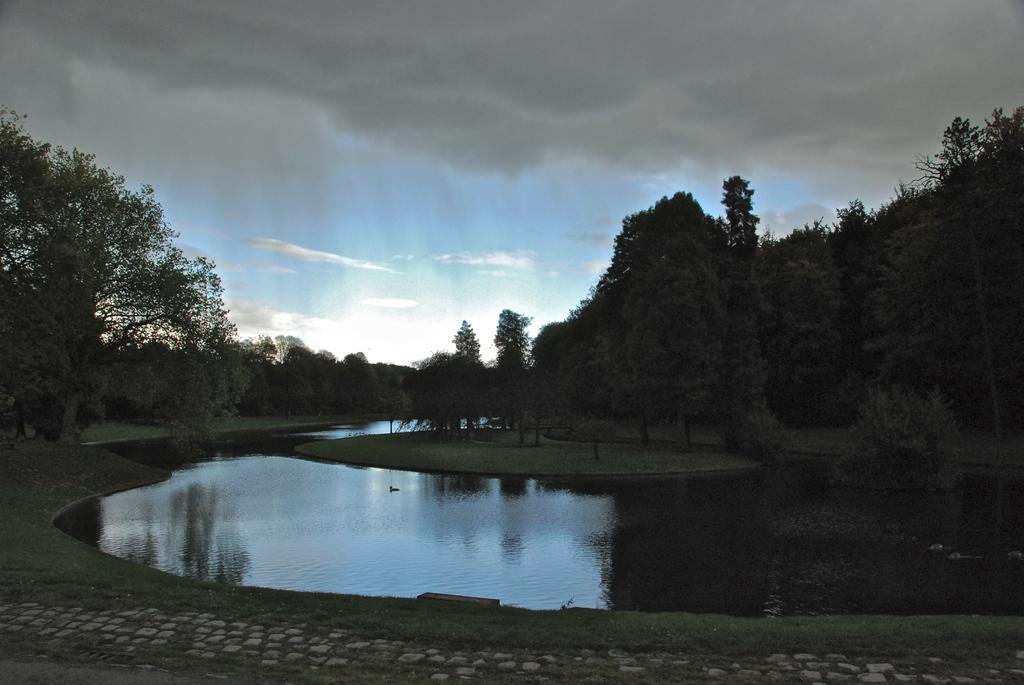What is the main feature in the center of the image? There is a lake in the center of the image. What can be seen at the bottom of the image? There is a walkway at the bottom of the image. What type of vegetation is visible in the background of the image? There are trees and grass in the background of the image. What is visible at the top of the image? The sky is visible at the top of the image. What type of ship can be seen sailing on the lake in the image? There is no ship present in the image; it only features a lake, walkway, trees, grass, and the sky. What kind of insect is crawling on the trees in the background of the image? There are no insects visible on the trees in the image; only trees and grass are present in the background. 